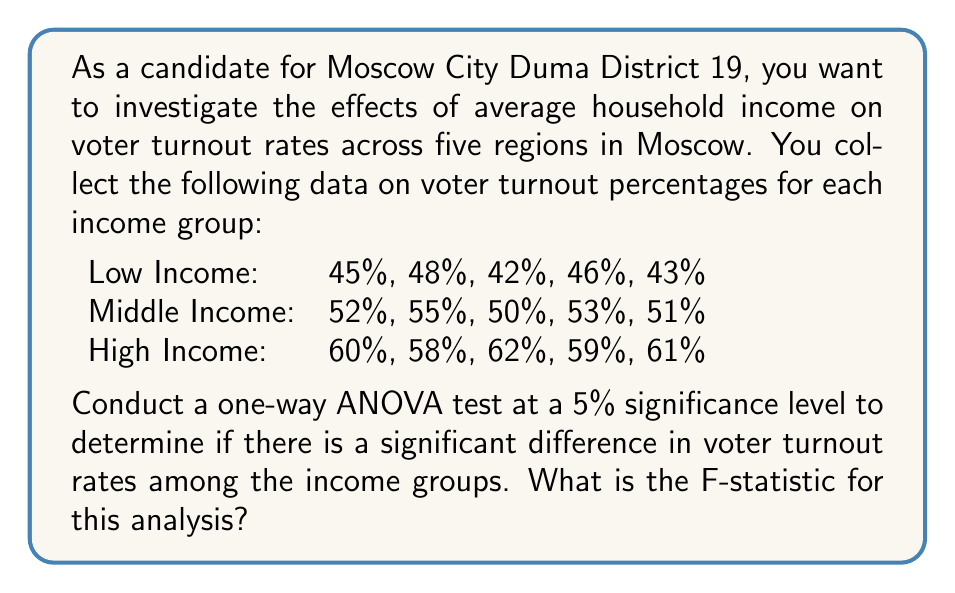Provide a solution to this math problem. To conduct a one-way ANOVA test, we need to follow these steps:

1. Calculate the sum of squares between groups (SSB)
2. Calculate the sum of squares within groups (SSW)
3. Calculate the degrees of freedom for between groups (dfB) and within groups (dfW)
4. Calculate the mean square between groups (MSB) and within groups (MSW)
5. Calculate the F-statistic

Step 1: Calculate SSB

First, we need to find the grand mean and group means:

Grand mean: $\bar{X} = \frac{45+48+42+46+43+52+55+50+53+51+60+58+62+59+61}{15} = 52.33$

Low Income mean: $\bar{X}_L = 44.8$
Middle Income mean: $\bar{X}_M = 52.2$
High Income mean: $\bar{X}_H = 60$

Now, we can calculate SSB:

$$SSB = n_L(\bar{X}_L - \bar{X})^2 + n_M(\bar{X}_M - \bar{X})^2 + n_H(\bar{X}_H - \bar{X})^2$$
$$SSB = 5(44.8 - 52.33)^2 + 5(52.2 - 52.33)^2 + 5(60 - 52.33)^2$$
$$SSB = 5(56.7889) + 5(0.0169) + 5(58.7889) = 576.9735$$

Step 2: Calculate SSW

$$SSW = \sum_{i=1}^{k}\sum_{j=1}^{n_i} (X_{ij} - \bar{X}_i)^2$$

For Low Income: $(45-44.8)^2 + (48-44.8)^2 + (42-44.8)^2 + (46-44.8)^2 + (43-44.8)^2 = 22.8$
For Middle Income: $(52-52.2)^2 + (55-52.2)^2 + (50-52.2)^2 + (53-52.2)^2 + (51-52.2)^2 = 14.8$
For High Income: $(60-60)^2 + (58-60)^2 + (62-60)^2 + (59-60)^2 + (61-60)^2 = 10$

$$SSW = 22.8 + 14.8 + 10 = 47.6$$

Step 3: Calculate degrees of freedom

dfB = k - 1 = 3 - 1 = 2 (k is the number of groups)
dfW = N - k = 15 - 3 = 12 (N is the total number of observations)

Step 4: Calculate mean squares

$$MSB = \frac{SSB}{dfB} = \frac{576.9735}{2} = 288.48675$$
$$MSW = \frac{SSW}{dfW} = \frac{47.6}{12} = 3.96667$$

Step 5: Calculate F-statistic

$$F = \frac{MSB}{MSW} = \frac{288.48675}{3.96667} = 72.73$$
Answer: The F-statistic for this one-way ANOVA analysis is 72.73. 